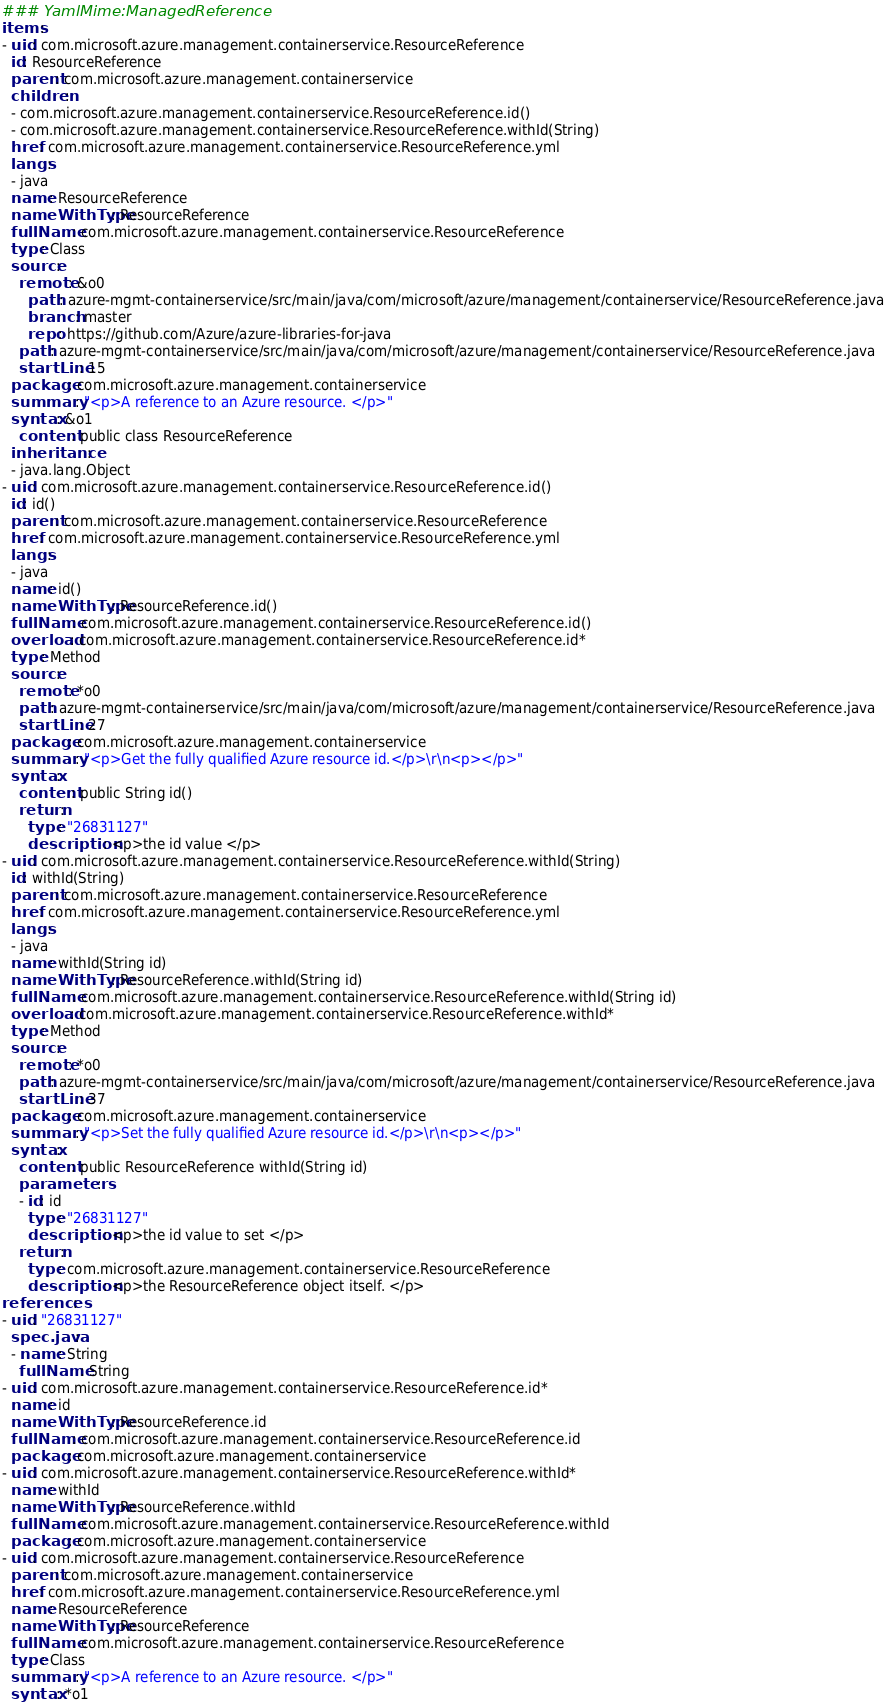<code> <loc_0><loc_0><loc_500><loc_500><_YAML_>### YamlMime:ManagedReference
items:
- uid: com.microsoft.azure.management.containerservice.ResourceReference
  id: ResourceReference
  parent: com.microsoft.azure.management.containerservice
  children:
  - com.microsoft.azure.management.containerservice.ResourceReference.id()
  - com.microsoft.azure.management.containerservice.ResourceReference.withId(String)
  href: com.microsoft.azure.management.containerservice.ResourceReference.yml
  langs:
  - java
  name: ResourceReference
  nameWithType: ResourceReference
  fullName: com.microsoft.azure.management.containerservice.ResourceReference
  type: Class
  source:
    remote: &o0
      path: azure-mgmt-containerservice/src/main/java/com/microsoft/azure/management/containerservice/ResourceReference.java
      branch: master
      repo: https://github.com/Azure/azure-libraries-for-java
    path: azure-mgmt-containerservice/src/main/java/com/microsoft/azure/management/containerservice/ResourceReference.java
    startLine: 15
  package: com.microsoft.azure.management.containerservice
  summary: "<p>A reference to an Azure resource. </p>"
  syntax: &o1
    content: public class ResourceReference
  inheritance:
  - java.lang.Object
- uid: com.microsoft.azure.management.containerservice.ResourceReference.id()
  id: id()
  parent: com.microsoft.azure.management.containerservice.ResourceReference
  href: com.microsoft.azure.management.containerservice.ResourceReference.yml
  langs:
  - java
  name: id()
  nameWithType: ResourceReference.id()
  fullName: com.microsoft.azure.management.containerservice.ResourceReference.id()
  overload: com.microsoft.azure.management.containerservice.ResourceReference.id*
  type: Method
  source:
    remote: *o0
    path: azure-mgmt-containerservice/src/main/java/com/microsoft/azure/management/containerservice/ResourceReference.java
    startLine: 27
  package: com.microsoft.azure.management.containerservice
  summary: "<p>Get the fully qualified Azure resource id.</p>\r\n<p></p>"
  syntax:
    content: public String id()
    return:
      type: "26831127"
      description: <p>the id value </p>
- uid: com.microsoft.azure.management.containerservice.ResourceReference.withId(String)
  id: withId(String)
  parent: com.microsoft.azure.management.containerservice.ResourceReference
  href: com.microsoft.azure.management.containerservice.ResourceReference.yml
  langs:
  - java
  name: withId(String id)
  nameWithType: ResourceReference.withId(String id)
  fullName: com.microsoft.azure.management.containerservice.ResourceReference.withId(String id)
  overload: com.microsoft.azure.management.containerservice.ResourceReference.withId*
  type: Method
  source:
    remote: *o0
    path: azure-mgmt-containerservice/src/main/java/com/microsoft/azure/management/containerservice/ResourceReference.java
    startLine: 37
  package: com.microsoft.azure.management.containerservice
  summary: "<p>Set the fully qualified Azure resource id.</p>\r\n<p></p>"
  syntax:
    content: public ResourceReference withId(String id)
    parameters:
    - id: id
      type: "26831127"
      description: <p>the id value to set </p>
    return:
      type: com.microsoft.azure.management.containerservice.ResourceReference
      description: <p>the ResourceReference object itself. </p>
references:
- uid: "26831127"
  spec.java:
  - name: String
    fullName: String
- uid: com.microsoft.azure.management.containerservice.ResourceReference.id*
  name: id
  nameWithType: ResourceReference.id
  fullName: com.microsoft.azure.management.containerservice.ResourceReference.id
  package: com.microsoft.azure.management.containerservice
- uid: com.microsoft.azure.management.containerservice.ResourceReference.withId*
  name: withId
  nameWithType: ResourceReference.withId
  fullName: com.microsoft.azure.management.containerservice.ResourceReference.withId
  package: com.microsoft.azure.management.containerservice
- uid: com.microsoft.azure.management.containerservice.ResourceReference
  parent: com.microsoft.azure.management.containerservice
  href: com.microsoft.azure.management.containerservice.ResourceReference.yml
  name: ResourceReference
  nameWithType: ResourceReference
  fullName: com.microsoft.azure.management.containerservice.ResourceReference
  type: Class
  summary: "<p>A reference to an Azure resource. </p>"
  syntax: *o1
</code> 